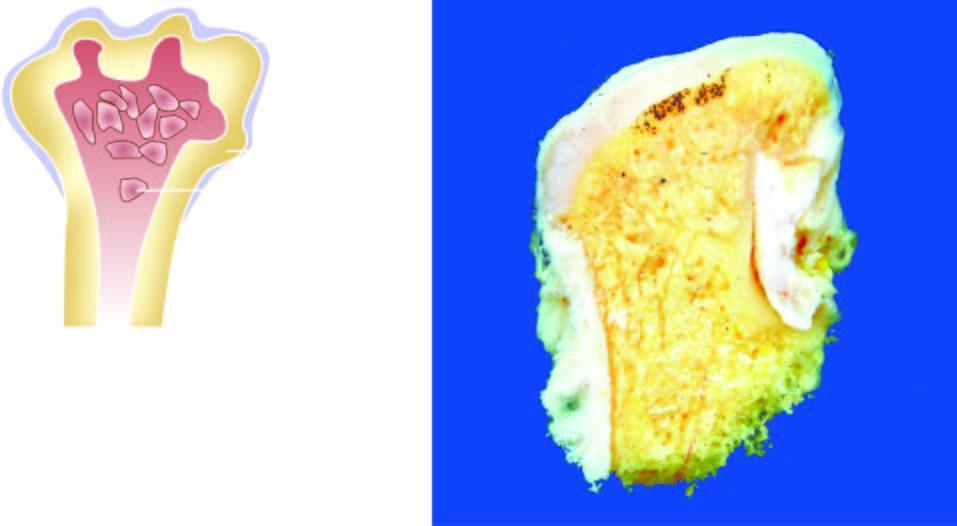what have cartilaginous caps and inner osseous tissue?
Answer the question using a single word or phrase. Nodules 